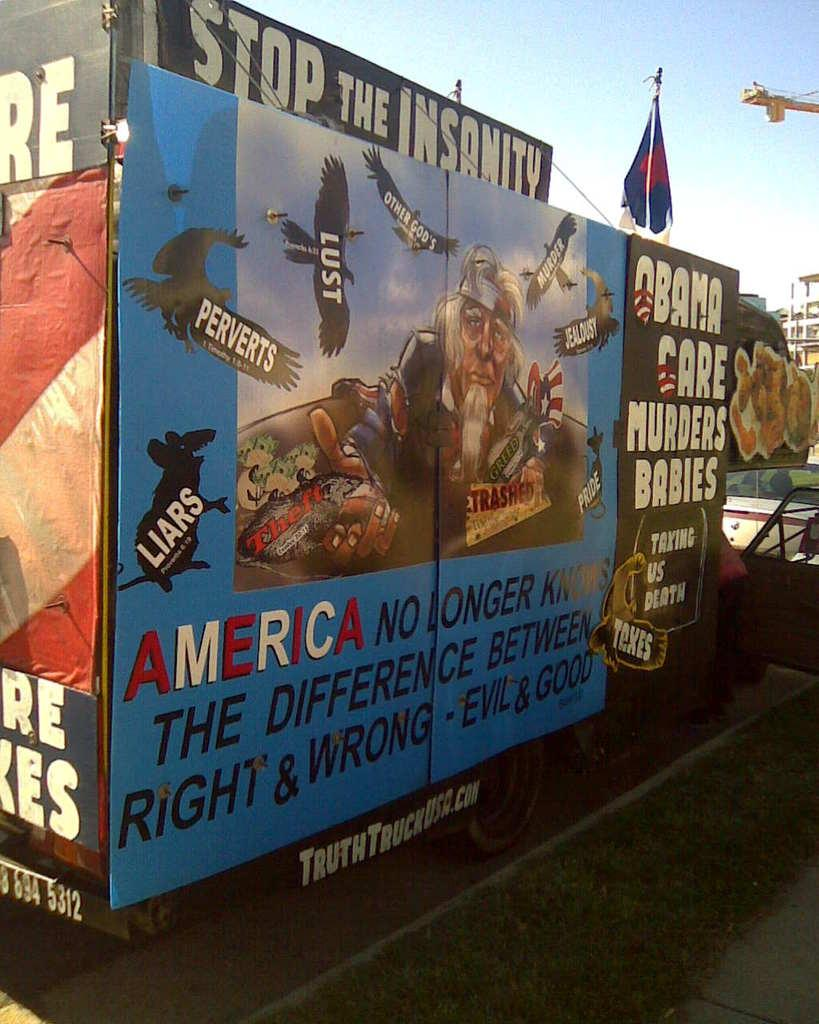What is the main feature of the image? There is a track in the image. What is depicted on the track? There is a cartoon image of a person on the track. What else can be seen in the image besides the track and person? There is text, a bird, and a building on the right side of the image. What is visible in the background of the image? The sky is visible in the image. How many oranges are being used to support the theory in the image? There are no oranges or theories present in the image. Is there a bike visible in the image? No, there is no bike visible in the image. 